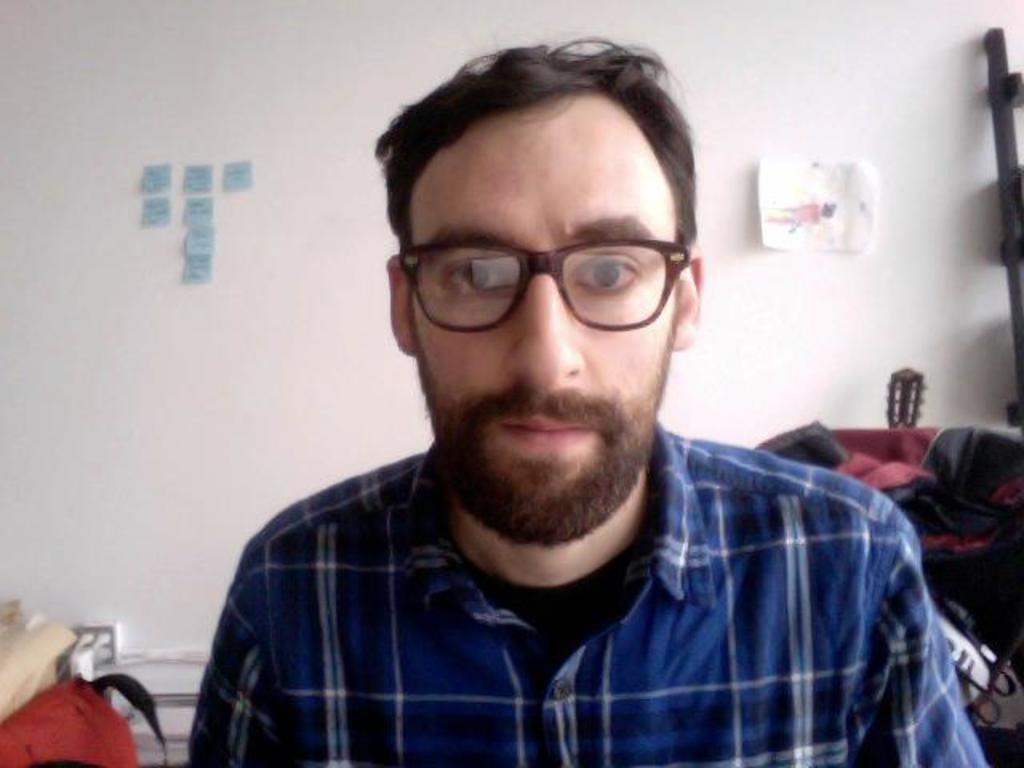What is present in the image? There is a man in the image. Can you describe the man's clothing? The man is wearing a shirt and spectacles. What can be seen on the wall in the image? There are sticky notes and a paper attached to the wall. What is visible in the background of the image? There are objects in the background of the image. How many trucks are parked in the north direction in the image? There are no trucks or any indication of a north direction in the image. 